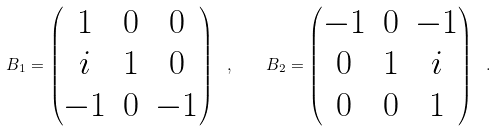Convert formula to latex. <formula><loc_0><loc_0><loc_500><loc_500>B _ { 1 } = \left ( \begin{matrix} 1 & 0 & 0 \\ i & 1 & 0 \\ - 1 & 0 & - 1 \end{matrix} \right ) \ , \quad B _ { 2 } = \left ( \begin{matrix} - 1 & 0 & - 1 \\ 0 & 1 & i \\ 0 & 0 & 1 \end{matrix} \right ) \ .</formula> 